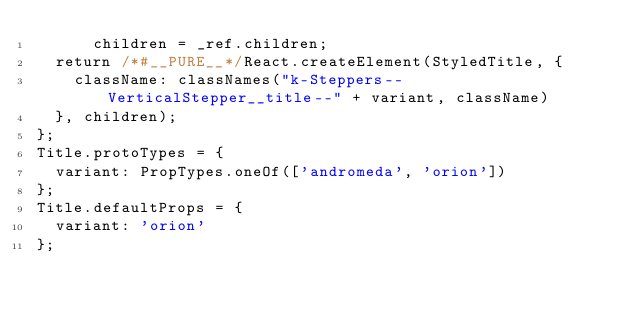Convert code to text. <code><loc_0><loc_0><loc_500><loc_500><_JavaScript_>      children = _ref.children;
  return /*#__PURE__*/React.createElement(StyledTitle, {
    className: classNames("k-Steppers--VerticalStepper__title--" + variant, className)
  }, children);
};
Title.protoTypes = {
  variant: PropTypes.oneOf(['andromeda', 'orion'])
};
Title.defaultProps = {
  variant: 'orion'
};</code> 